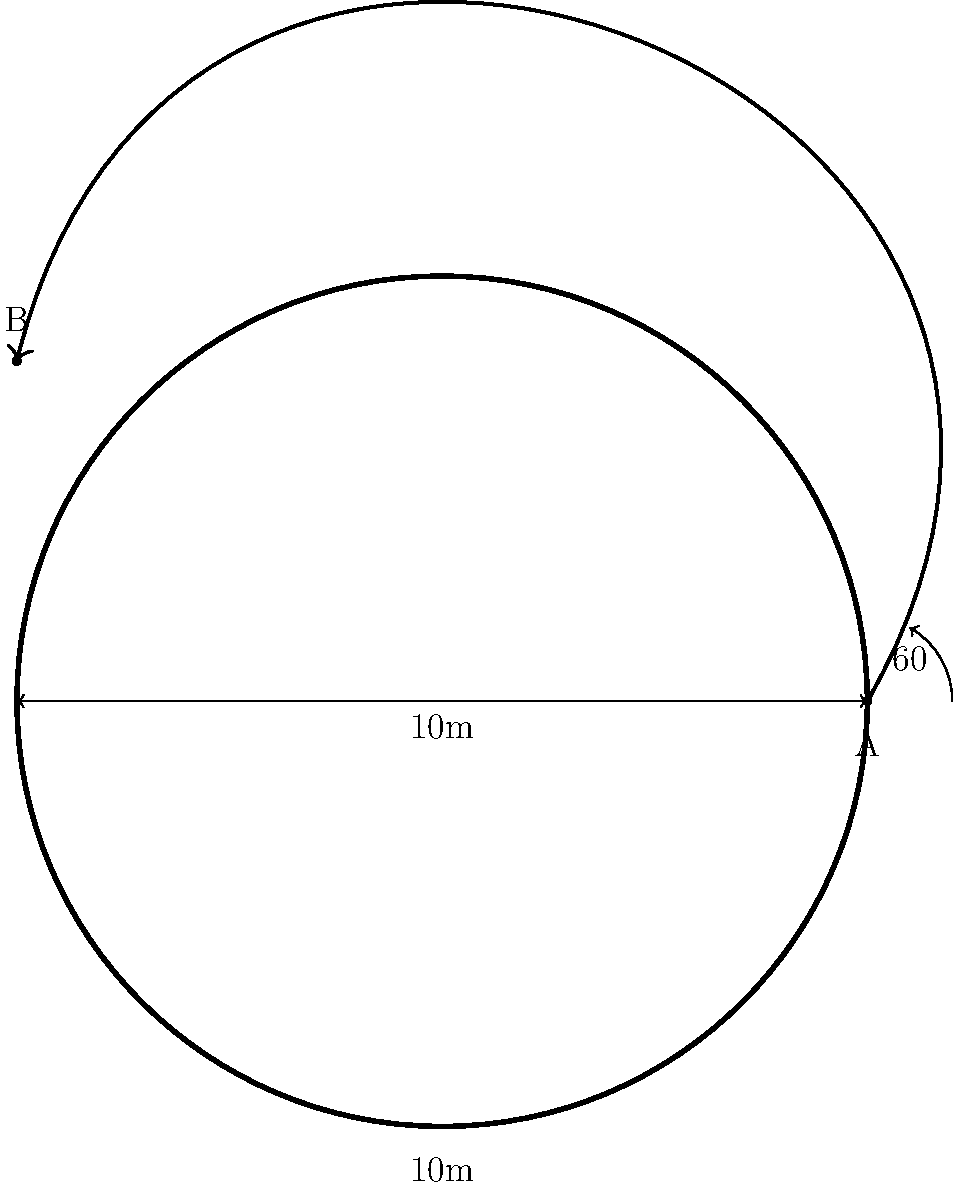In a wXw match, a high-flying wrestler performs an aerial move from corner A to corner B of a square ring. The wrestler launches at a 60° angle from the horizontal. If the ring is 10m wide, what is the maximum height reached by the wrestler during the move? To solve this problem, we'll use the principles of projectile motion. Let's break it down step-by-step:

1) First, we need to find the time it takes for the wrestler to reach the other corner. We can use the horizontal displacement equation:

   $x = v_0 \cos(\theta) \cdot t$

   Where $x$ is the width of the ring (10m), $v_0$ is the initial velocity, $\theta$ is the launch angle (60°), and $t$ is the time.

2) We don't know the initial velocity, but we can eliminate it by using the vertical displacement equation:

   $y = v_0 \sin(\theta) \cdot t - \frac{1}{2}gt^2$

   Where $y$ is the vertical displacement (0m, as the wrestler starts and ends at the same height), and $g$ is the acceleration due to gravity (9.8 m/s²).

3) From the horizontal equation, we can express $v_0$ in terms of $t$:

   $v_0 = \frac{x}{t \cos(\theta)} = \frac{10}{t \cos(60°)}$

4) Substituting this into the vertical equation:

   $0 = \frac{10}{t \cos(60°)} \sin(60°) \cdot t - \frac{1}{2}g t^2$

5) Simplifying:

   $0 = \frac{10 \sin(60°)}{\cos(60°)} - \frac{1}{2}g t^2$

6) Solving for $t$:

   $t = \sqrt{\frac{20 \sin(60°)}{g \cos(60°)}} \approx 1.37$ seconds

7) Now that we have $t$, we can find the maximum height. This occurs at half the total time:

   $h_{max} = v_0 \sin(\theta) \cdot \frac{t}{2} - \frac{1}{2}g (\frac{t}{2})^2$

8) Substituting the values:

   $h_{max} = \frac{10}{1.37 \cos(60°)} \sin(60°) \cdot \frac{1.37}{2} - \frac{1}{2}(9.8) (\frac{1.37}{2})^2$

9) Calculating:

   $h_{max} \approx 2.17$ meters

Therefore, the maximum height reached by the wrestler during the move is approximately 2.17 meters.
Answer: 2.17 meters 